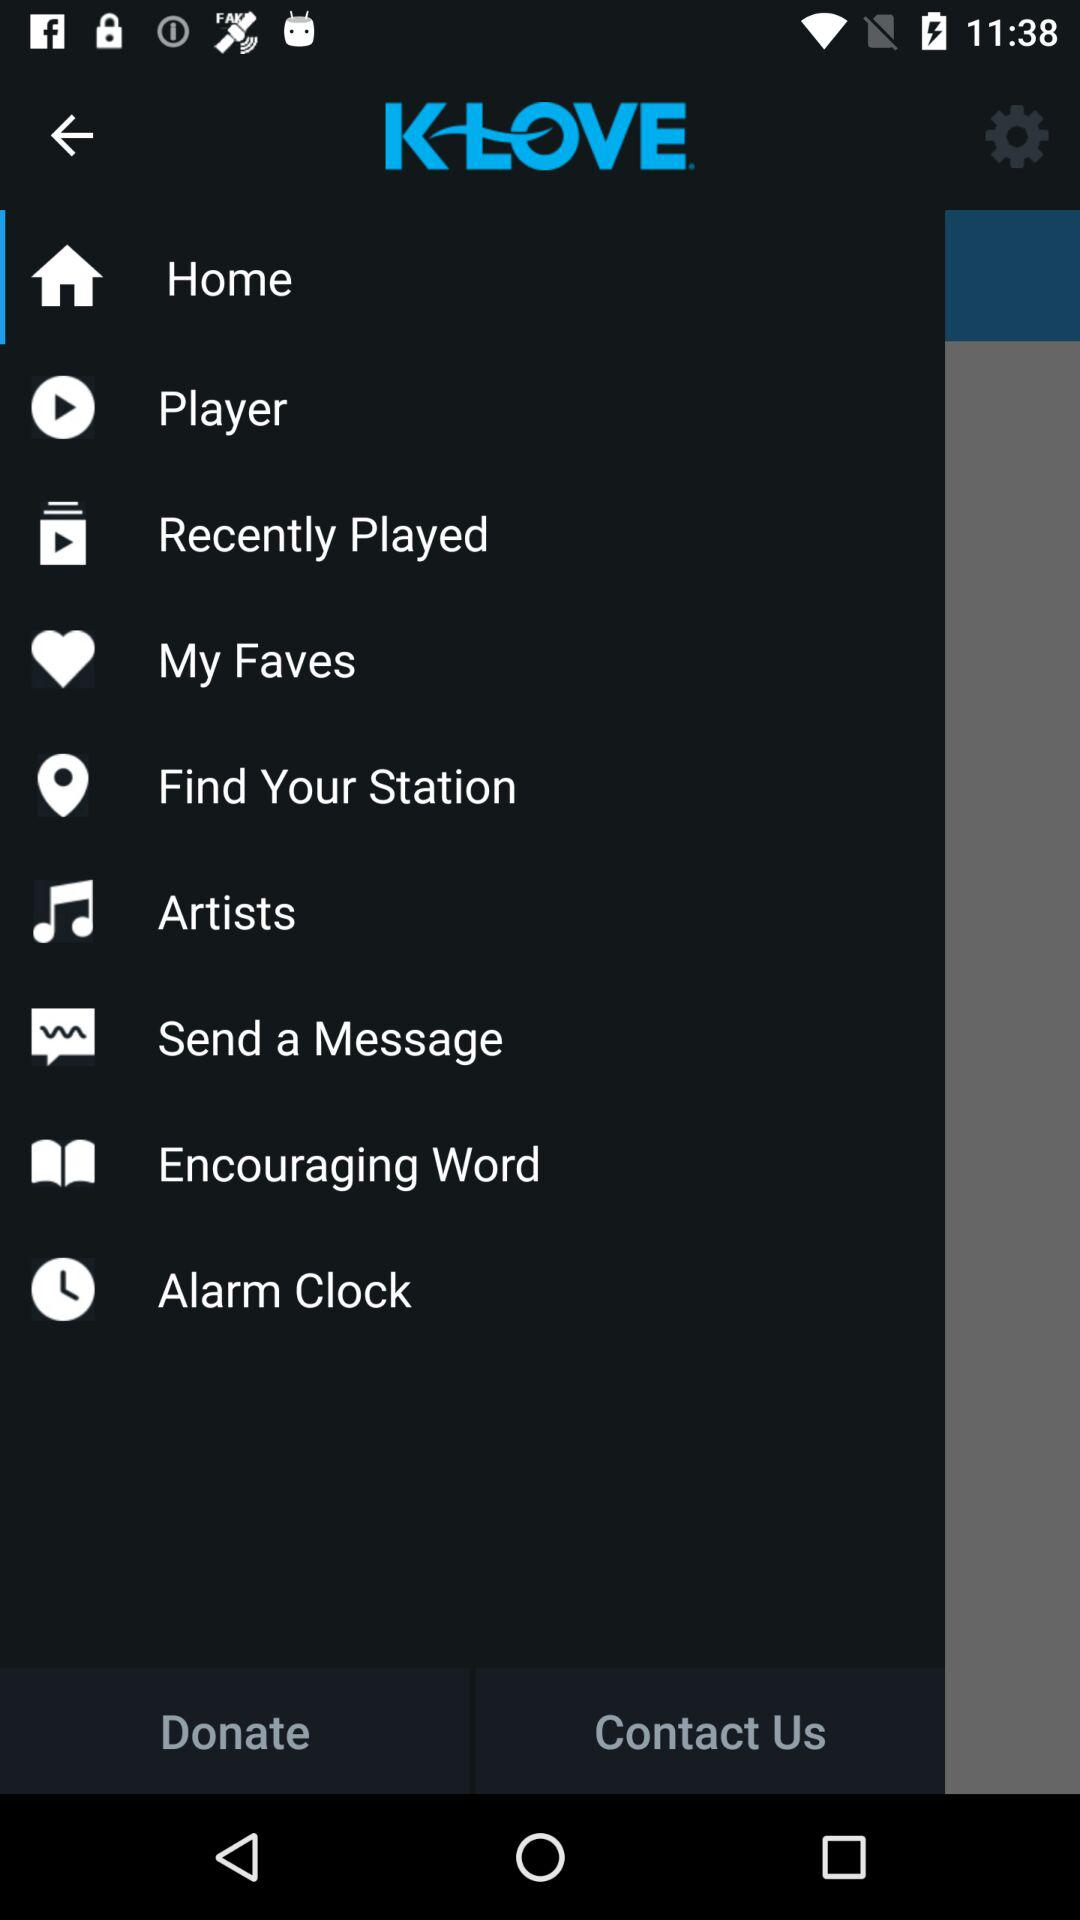What is the application name? The application name is "K-LOVE". 